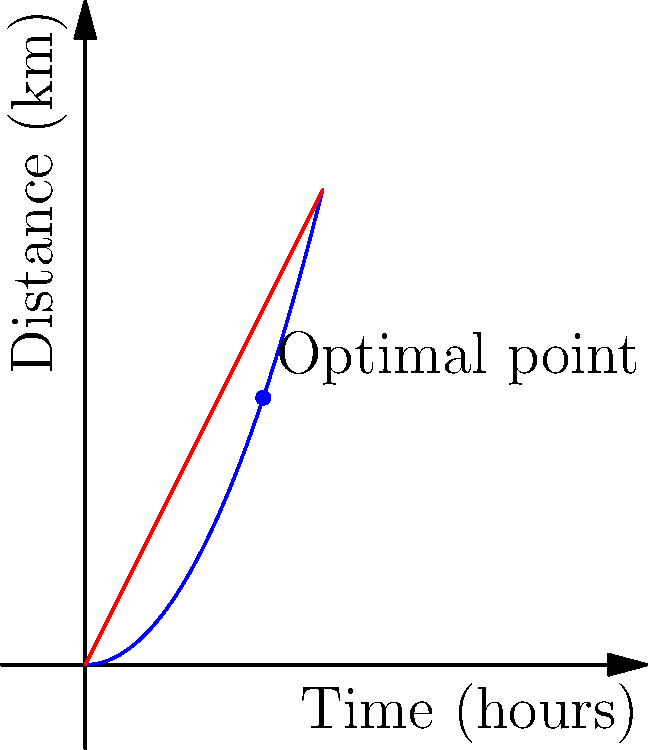You plan to photograph the sunrise at Brockhall, which is 6 km away. If you start walking 3 hours before sunrise and your walking pace increases quadratically with time, what should your initial walking speed be to arrive just in time for the sunrise? Let's approach this step-by-step:

1) Let's define our variables:
   $t$ = time in hours
   $v(t)$ = velocity at time $t$ in km/h
   $s(t)$ = distance covered at time $t$ in km

2) We're told that the walking pace increases quadratically with time. Let's assume the form:
   $v(t) = at^2 + b$, where $a$ and $b$ are constants we need to determine.

3) To find the distance covered, we integrate the velocity:
   $s(t) = \int_0^t v(t) dt = \int_0^t (at^2 + b) dt = \frac{1}{3}at^3 + bt$

4) We know two conditions:
   - At $t=3$ hours, $s(3) = 6$ km (total distance)
   - At $t=0$, $v(0) = b$ (initial speed)

5) Using the first condition:
   $6 = \frac{1}{3}a(3^3) + 3b$
   $6 = 9a + 3b$ ... (Equation 1)

6) We need another equation. Let's use the fact that the average speed over the journey should be 2 km/h (6 km / 3 hours):
   $\frac{1}{3}\int_0^3 (at^2 + b) dt = 2$
   $\frac{1}{3}(\frac{1}{3}a(3^3) + 3b) = 2$
   $3a + b = 2$ ... (Equation 2)

7) Solving Equations 1 and 2 simultaneously:
   From Equation 2: $b = 2 - 3a$
   Substituting in Equation 1: $6 = 9a + 3(2-3a) = 6 - 0a$

8) This means our assumption fits perfectly. From Equation 2:
   $b = 2 - 3a = 2 - 3(0) = 2$

Therefore, the initial walking speed (at $t=0$) should be 2 km/h.
Answer: 2 km/h 